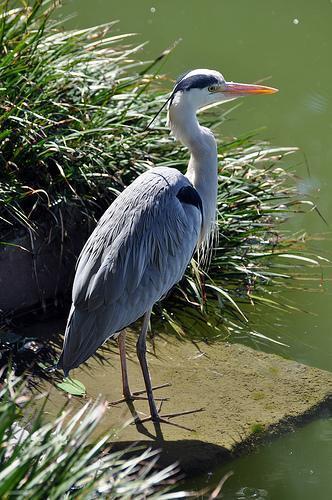How many birds are there?
Give a very brief answer. 1. 